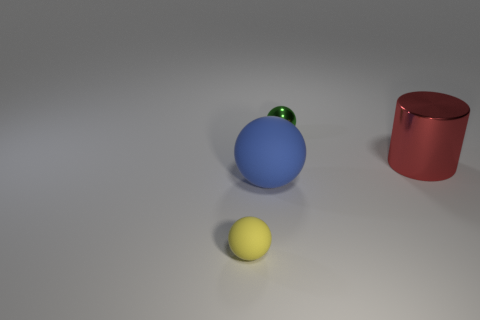Add 2 blue blocks. How many objects exist? 6 Subtract all spheres. How many objects are left? 1 Add 1 blue matte objects. How many blue matte objects exist? 2 Subtract 0 gray cylinders. How many objects are left? 4 Subtract all cyan rubber cylinders. Subtract all blue rubber spheres. How many objects are left? 3 Add 4 red cylinders. How many red cylinders are left? 5 